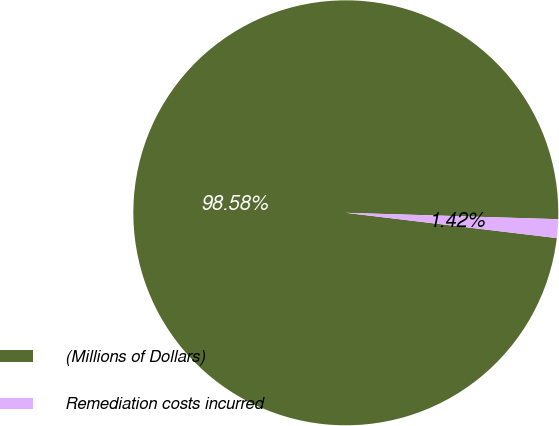Convert chart to OTSL. <chart><loc_0><loc_0><loc_500><loc_500><pie_chart><fcel>(Millions of Dollars)<fcel>Remediation costs incurred<nl><fcel>98.58%<fcel>1.42%<nl></chart> 